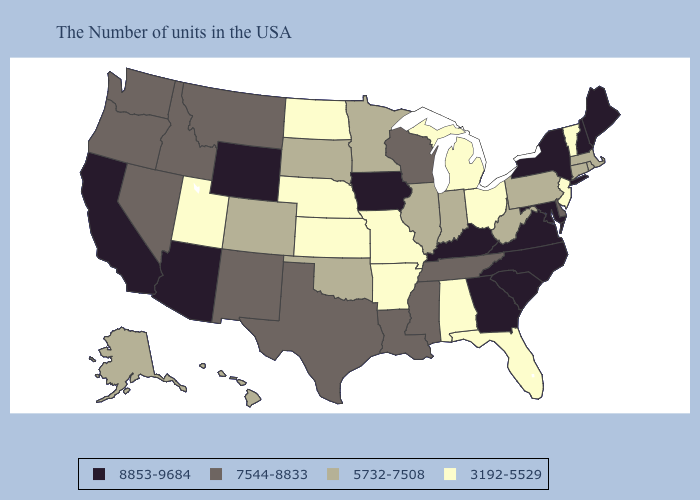Name the states that have a value in the range 8853-9684?
Concise answer only. Maine, New Hampshire, New York, Maryland, Virginia, North Carolina, South Carolina, Georgia, Kentucky, Iowa, Wyoming, Arizona, California. Does North Dakota have a lower value than Georgia?
Write a very short answer. Yes. Does Minnesota have the lowest value in the MidWest?
Quick response, please. No. Which states have the lowest value in the Northeast?
Keep it brief. Vermont, New Jersey. Name the states that have a value in the range 5732-7508?
Give a very brief answer. Massachusetts, Rhode Island, Connecticut, Pennsylvania, West Virginia, Indiana, Illinois, Minnesota, Oklahoma, South Dakota, Colorado, Alaska, Hawaii. Does Arkansas have the lowest value in the USA?
Be succinct. Yes. Which states have the lowest value in the USA?
Short answer required. Vermont, New Jersey, Ohio, Florida, Michigan, Alabama, Missouri, Arkansas, Kansas, Nebraska, North Dakota, Utah. Name the states that have a value in the range 8853-9684?
Quick response, please. Maine, New Hampshire, New York, Maryland, Virginia, North Carolina, South Carolina, Georgia, Kentucky, Iowa, Wyoming, Arizona, California. What is the value of Rhode Island?
Answer briefly. 5732-7508. Does North Dakota have the lowest value in the USA?
Give a very brief answer. Yes. Does Delaware have the same value as Indiana?
Write a very short answer. No. Among the states that border West Virginia , which have the lowest value?
Answer briefly. Ohio. Does Utah have the lowest value in the West?
Write a very short answer. Yes. Name the states that have a value in the range 8853-9684?
Be succinct. Maine, New Hampshire, New York, Maryland, Virginia, North Carolina, South Carolina, Georgia, Kentucky, Iowa, Wyoming, Arizona, California. What is the value of North Dakota?
Be succinct. 3192-5529. 